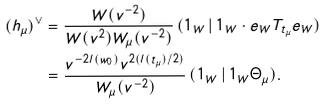Convert formula to latex. <formula><loc_0><loc_0><loc_500><loc_500>( h _ { \mu } ) ^ { \vee } & = \frac { W ( v ^ { - 2 } ) } { W ( v ^ { 2 } ) W _ { \mu } ( v ^ { - 2 } ) } \, ( 1 _ { W } \, | \, 1 _ { W } \cdot e _ { W } T _ { t _ { \mu } } e _ { W } ) \\ & = \frac { v ^ { - 2 l ( w _ { 0 } ) } v ^ { 2 ( l ( t _ { \mu } ) / 2 ) } } { W _ { \mu } ( v ^ { - 2 } ) } \, ( 1 _ { W } \, | \, 1 _ { W } \Theta _ { \mu } ) .</formula> 